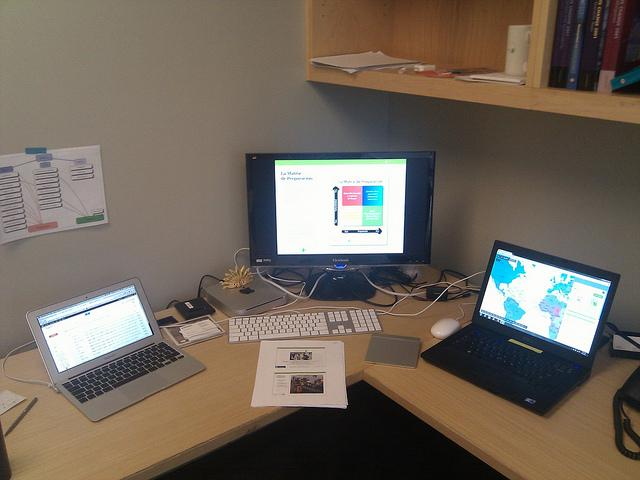On which computer could one find directions the fastest?

Choices:
A) middle
B) left
C) none
D) right right 